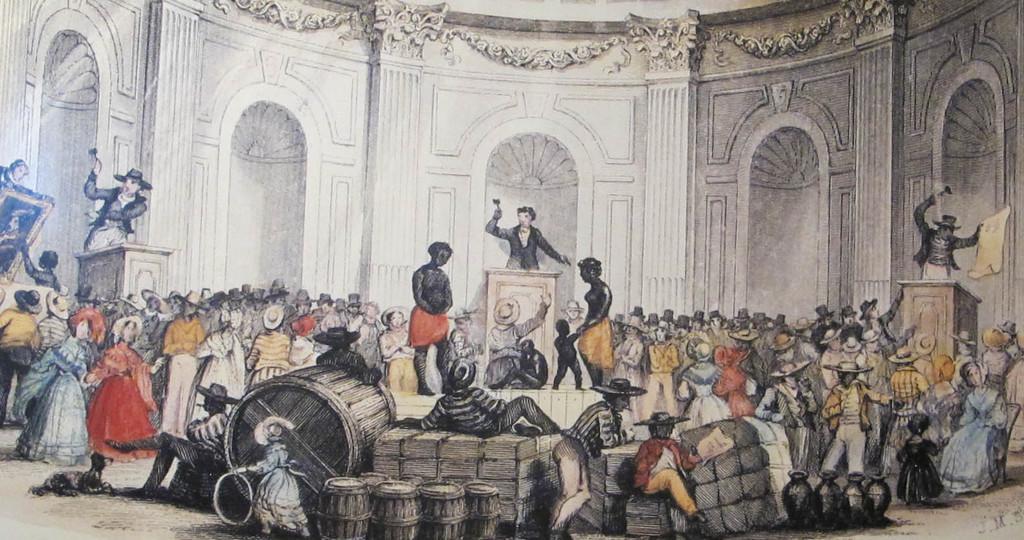Please provide a concise description of this image. In this picture there is a drawing photography. In the front there are many men and women standing in the hall. In the middle there is a white stone on the top we can see a man standing and giving a speech. Behind there is a white color arch wall. 